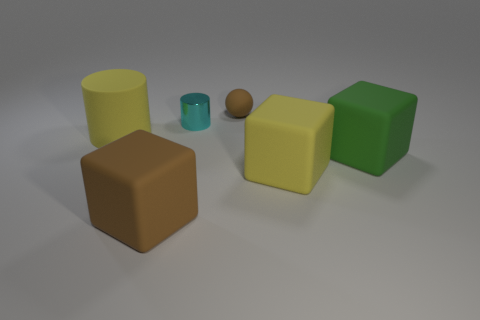Add 4 brown spheres. How many objects exist? 10 Subtract all spheres. How many objects are left? 5 Subtract all small cyan metal things. Subtract all big rubber cubes. How many objects are left? 2 Add 1 big matte cylinders. How many big matte cylinders are left? 2 Add 3 tiny brown balls. How many tiny brown balls exist? 4 Subtract 0 brown cylinders. How many objects are left? 6 